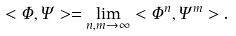Convert formula to latex. <formula><loc_0><loc_0><loc_500><loc_500>< \Phi , \Psi > = \lim _ { n , m \to \infty } < \Phi ^ { n } , \Psi ^ { m } > .</formula> 